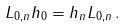Convert formula to latex. <formula><loc_0><loc_0><loc_500><loc_500>L _ { 0 , n } h _ { 0 } = h _ { n } L _ { 0 , n } \, .</formula> 